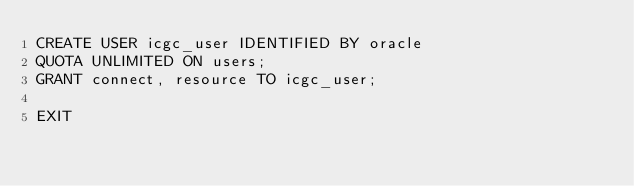Convert code to text. <code><loc_0><loc_0><loc_500><loc_500><_SQL_>CREATE USER icgc_user IDENTIFIED BY oracle
QUOTA UNLIMITED ON users;
GRANT connect, resource TO icgc_user;

EXIT
</code> 